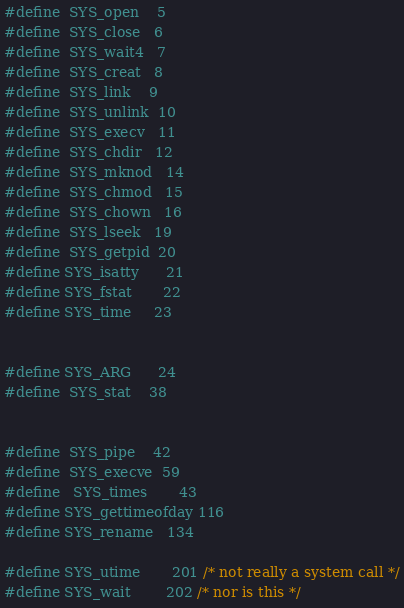Convert code to text. <code><loc_0><loc_0><loc_500><loc_500><_C_>#define	SYS_open	5
#define	SYS_close	6
#define	SYS_wait4	7
#define	SYS_creat	8
#define	SYS_link	9
#define	SYS_unlink	10
#define	SYS_execv	11
#define	SYS_chdir	12
#define	SYS_mknod	14
#define	SYS_chmod	15
#define	SYS_chown	16
#define	SYS_lseek	19
#define	SYS_getpid	20
#define SYS_isatty      21
#define SYS_fstat       22
#define SYS_time 	23


#define SYS_ARG		24
#define	SYS_stat	38


#define	SYS_pipe	42
#define	SYS_execve	59
#define   SYS_times       43
#define SYS_gettimeofday 116
#define SYS_rename	134

#define SYS_utime       201 /* not really a system call */
#define SYS_wait        202 /* nor is this */

</code> 